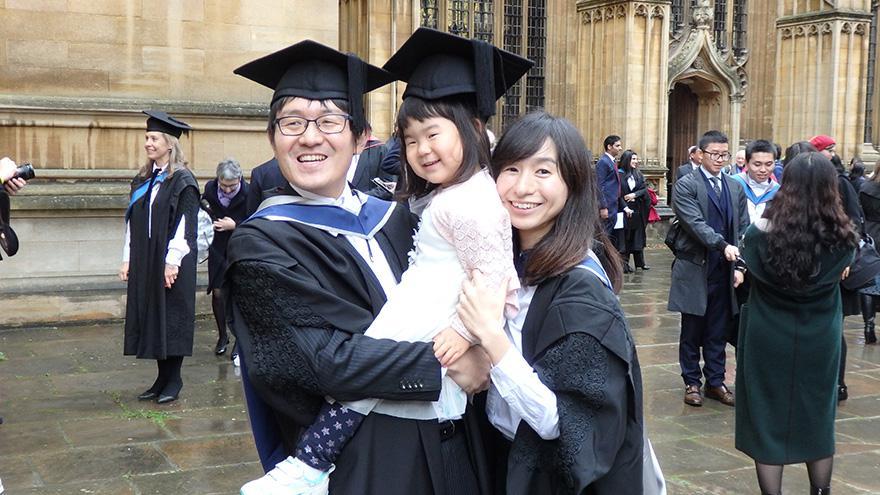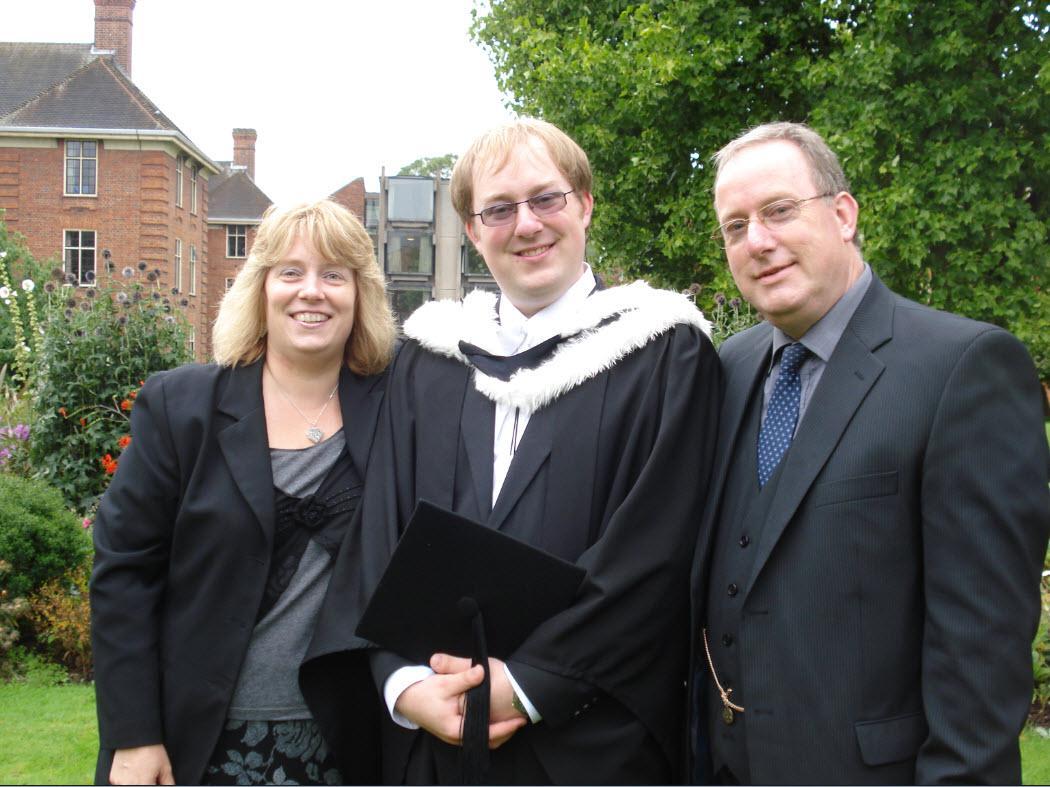The first image is the image on the left, the second image is the image on the right. For the images displayed, is the sentence "The people in the image on the right are standing near trees." factually correct? Answer yes or no. Yes. The first image is the image on the left, the second image is the image on the right. For the images shown, is this caption "The left image contains only males, posed side-to-side facing forward, and at least one of them is a black man wearing a graduation cap." true? Answer yes or no. No. 